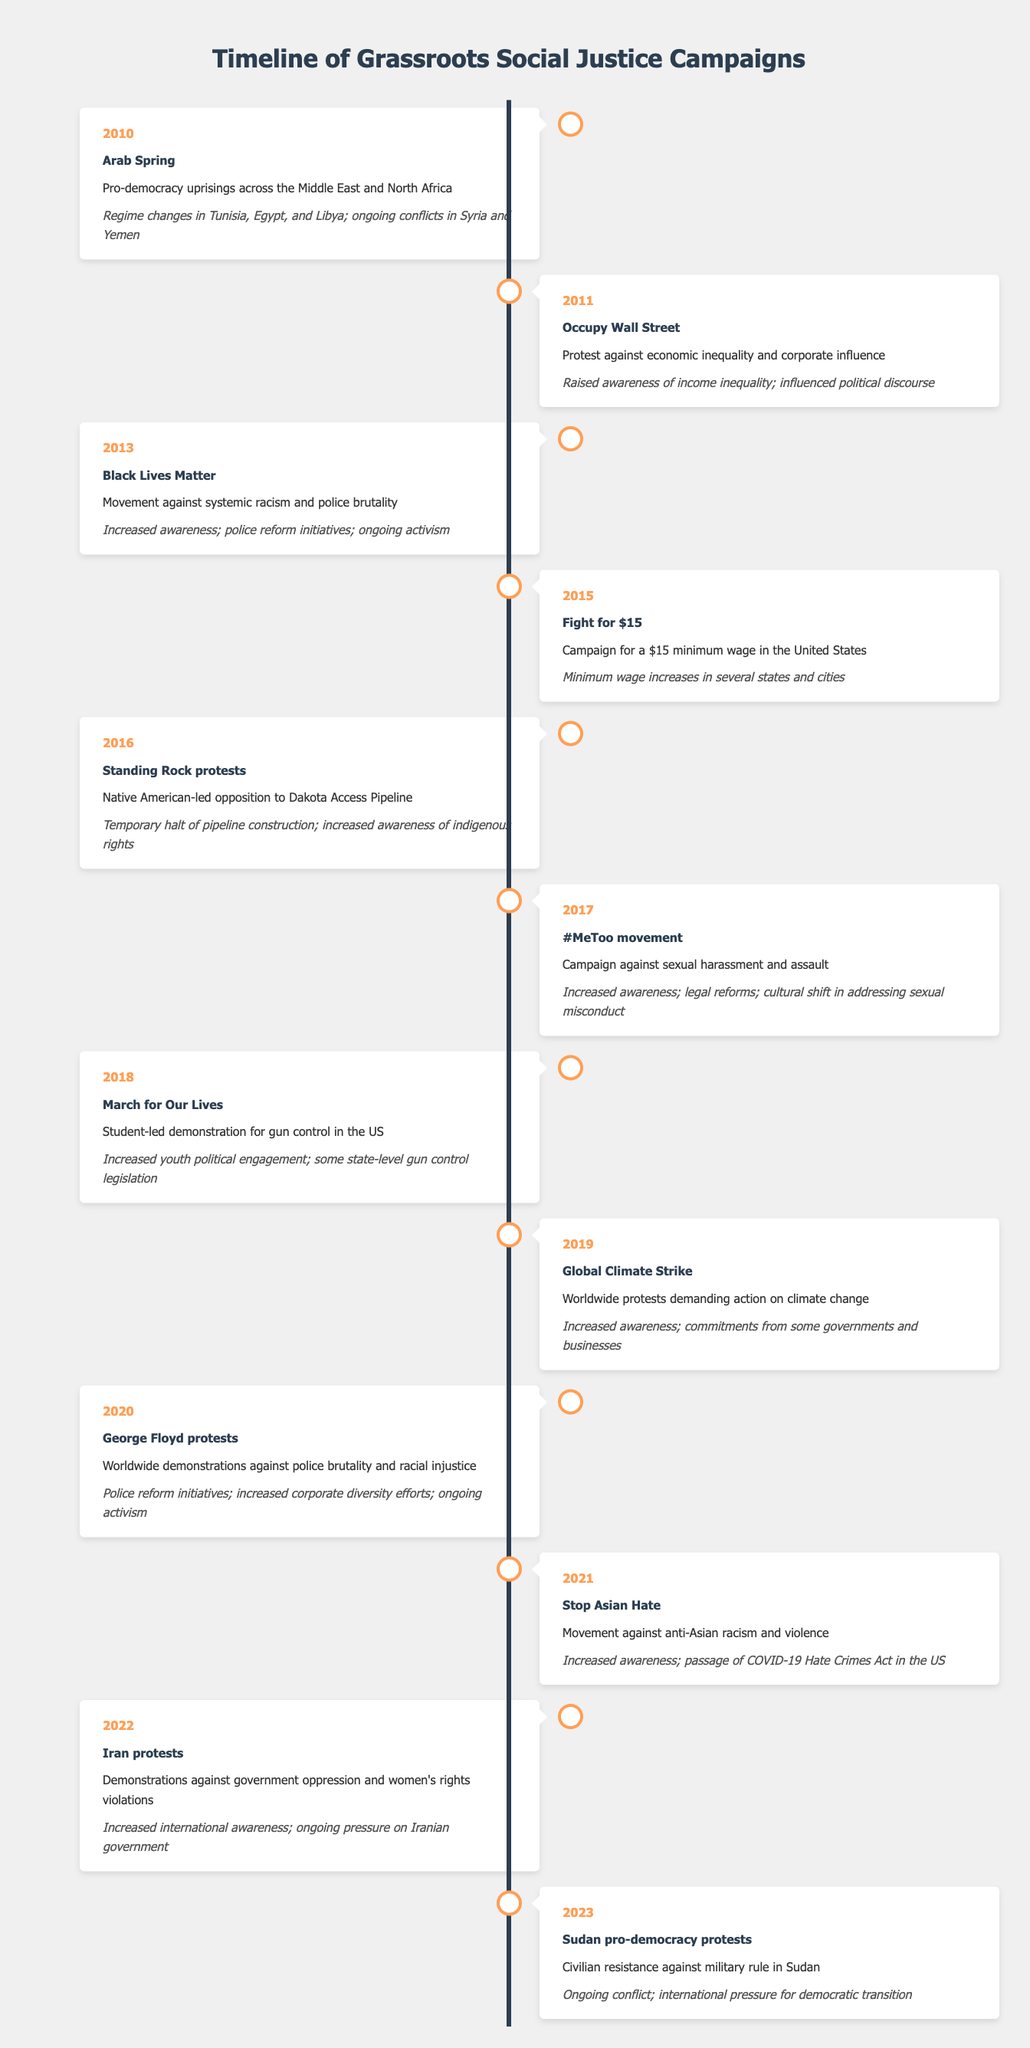What year did the Fight for $15 campaign occur? The column for the year lists the campaign "Fight for $15" in the row marked with the year 2015.
Answer: 2015 Which campaign from the timeline had a significant focus on gun control? In the timeline, the “March for Our Lives” campaign from 2018 specifically describes a student-led demonstration for gun control in the US.
Answer: March for Our Lives How many campaigns aimed to address police brutality or racial injustice? The campaigns “Black Lives Matter” in 2013, “George Floyd protests” in 2020, and “Stop Asian Hate” in 2021 all address issues of police brutality or racial injustice. There are three such campaigns.
Answer: 3 What was the outcome of the Standing Rock protests in 2016? The outcome listed for the Standing Rock protests is a temporary halt of pipeline construction and increased awareness of indigenous rights.
Answer: Temporary halt of pipeline construction; increased awareness of indigenous rights Was there any campaign that specifically addressed women's rights violations? Yes, the Iran protests in 2022 mentioned women's rights violations as a key issue in the demonstrations against government oppression.
Answer: Yes Which campaign had its outcome connected to international pressure? The campaigns for the Iran protests in 2022 and the Sudan pro-democracy protests in 2023 both mention ongoing pressure on their respective governments as an outcome.
Answer: Iran protests and Sudan pro-democracy protests What is the decade with the highest number of campaigns listed in the timeline? The timeline ranges from 2010 to 2023 and lists a total of 13 campaigns, seven of which are from the 2020s, showing that more campaigns occurred in this decade than any other in the table.
Answer: 2020s Which campaign resulted in legal reforms regarding sexual misconduct? The #MeToo movement in 2017 mentions increased awareness and legal reforms related to sexual harassment and assault.
Answer: #MeToo movement How many campaigns were focused on climate change? The Global Climate Strike campaign in 2019 is the only one mentioned that specifically focuses on demanding action on climate change.
Answer: 1 